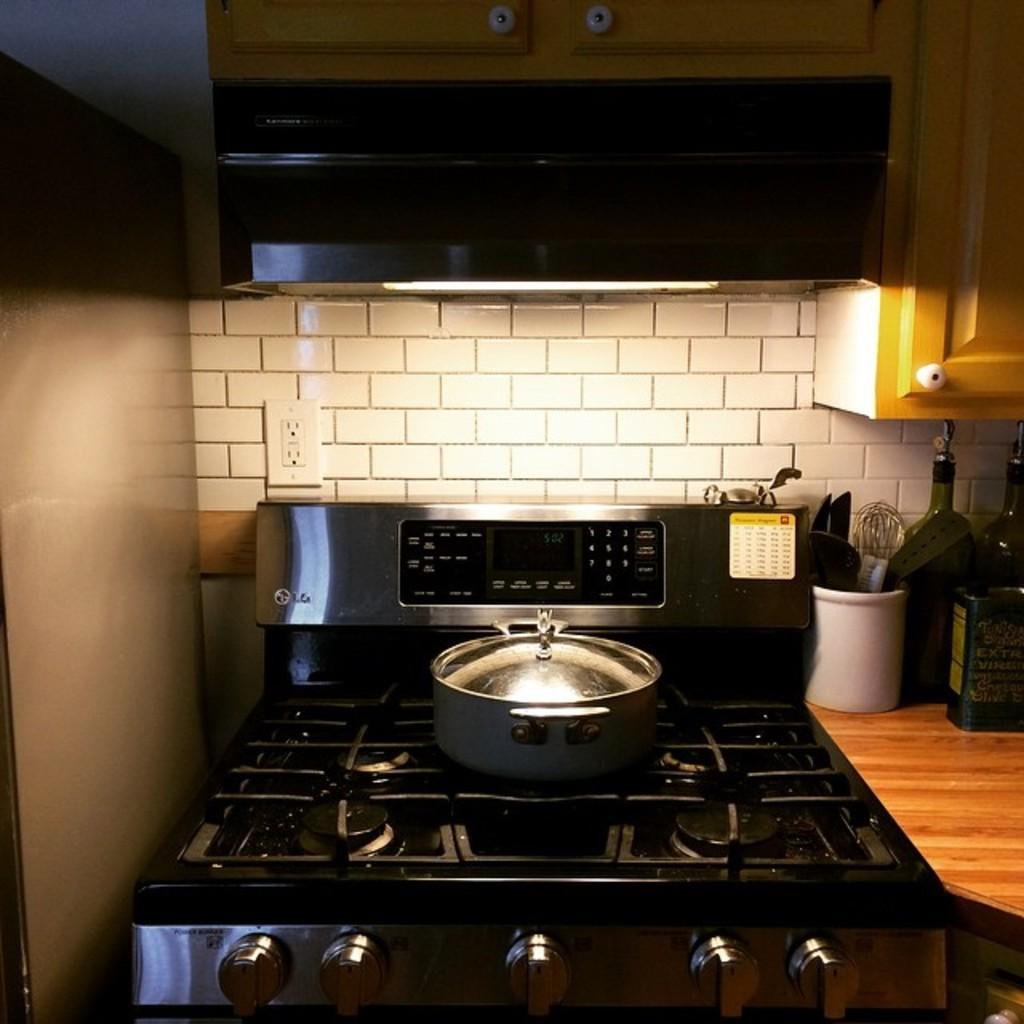In one or two sentences, can you explain what this image depicts? In this picture I can see a vessel on the stove, on the right side there are bottles, in the middle there is the light. 